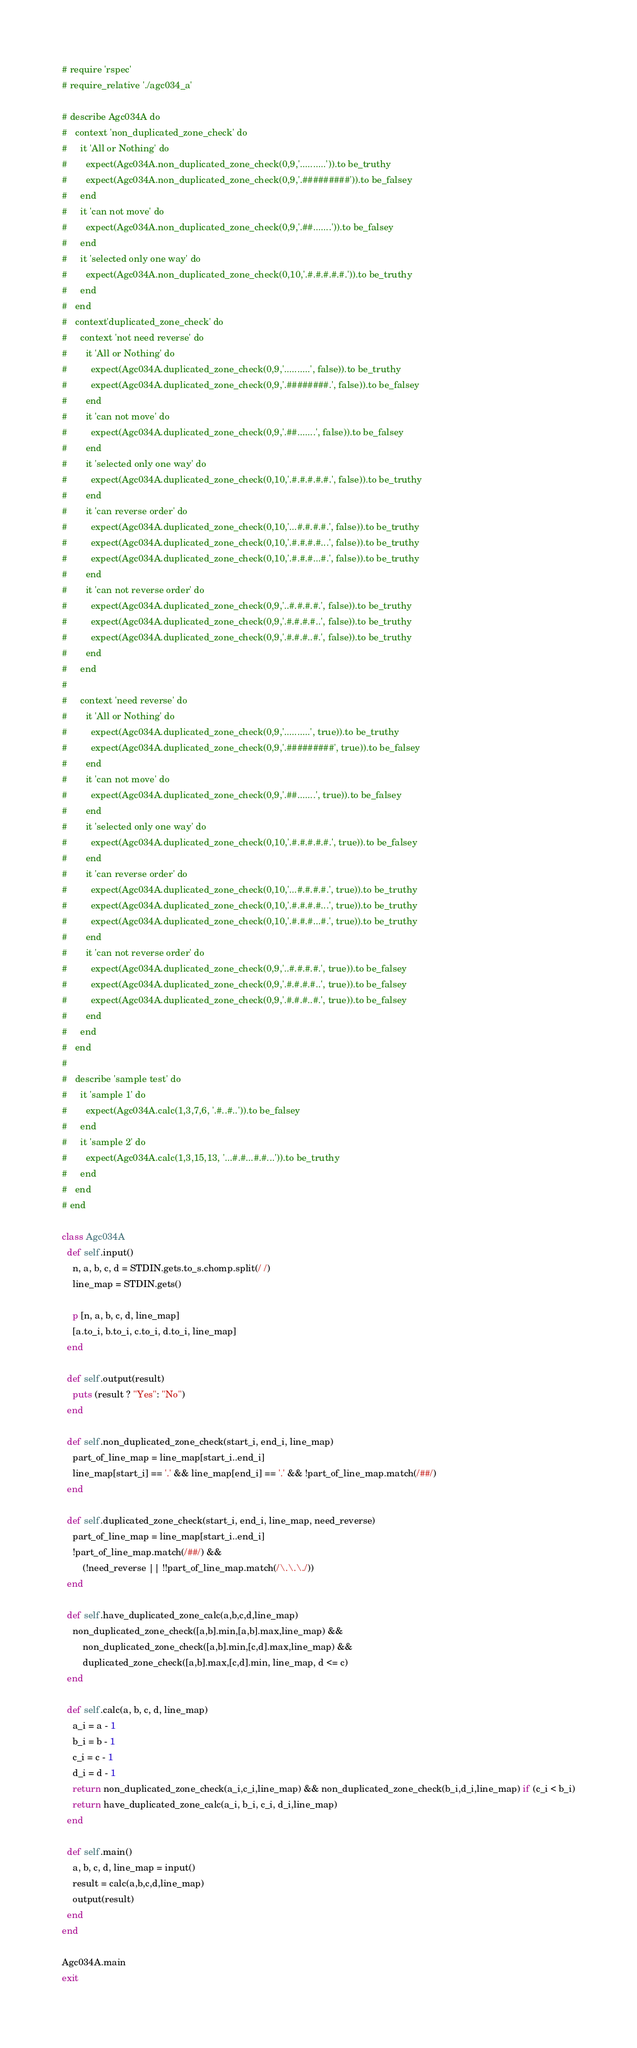Convert code to text. <code><loc_0><loc_0><loc_500><loc_500><_Ruby_># require 'rspec'
# require_relative './agc034_a'

# describe Agc034A do
#   context 'non_duplicated_zone_check' do
#     it 'All or Nothing' do
#       expect(Agc034A.non_duplicated_zone_check(0,9,'..........')).to be_truthy
#       expect(Agc034A.non_duplicated_zone_check(0,9,'.#########')).to be_falsey
#     end
#     it 'can not move' do
#       expect(Agc034A.non_duplicated_zone_check(0,9,'.##.......')).to be_falsey
#     end
#     it 'selected only one way' do
#       expect(Agc034A.non_duplicated_zone_check(0,10,'.#.#.#.#.#.')).to be_truthy
#     end
#   end
#   context'duplicated_zone_check' do
#     context 'not need reverse' do
#       it 'All or Nothing' do
#         expect(Agc034A.duplicated_zone_check(0,9,'..........', false)).to be_truthy
#         expect(Agc034A.duplicated_zone_check(0,9,'.########.', false)).to be_falsey
#       end
#       it 'can not move' do
#         expect(Agc034A.duplicated_zone_check(0,9,'.##.......', false)).to be_falsey
#       end
#       it 'selected only one way' do
#         expect(Agc034A.duplicated_zone_check(0,10,'.#.#.#.#.#.', false)).to be_truthy
#       end
#       it 'can reverse order' do
#         expect(Agc034A.duplicated_zone_check(0,10,'...#.#.#.#.', false)).to be_truthy
#         expect(Agc034A.duplicated_zone_check(0,10,'.#.#.#.#...', false)).to be_truthy
#         expect(Agc034A.duplicated_zone_check(0,10,'.#.#.#...#.', false)).to be_truthy
#       end
#       it 'can not reverse order' do
#         expect(Agc034A.duplicated_zone_check(0,9,'..#.#.#.#.', false)).to be_truthy
#         expect(Agc034A.duplicated_zone_check(0,9,'.#.#.#.#..', false)).to be_truthy
#         expect(Agc034A.duplicated_zone_check(0,9,'.#.#.#..#.', false)).to be_truthy
#       end
#     end
#
#     context 'need reverse' do
#       it 'All or Nothing' do
#         expect(Agc034A.duplicated_zone_check(0,9,'..........', true)).to be_truthy
#         expect(Agc034A.duplicated_zone_check(0,9,'.#########', true)).to be_falsey
#       end
#       it 'can not move' do
#         expect(Agc034A.duplicated_zone_check(0,9,'.##.......', true)).to be_falsey
#       end
#       it 'selected only one way' do
#         expect(Agc034A.duplicated_zone_check(0,10,'.#.#.#.#.#.', true)).to be_falsey
#       end
#       it 'can reverse order' do
#         expect(Agc034A.duplicated_zone_check(0,10,'...#.#.#.#.', true)).to be_truthy
#         expect(Agc034A.duplicated_zone_check(0,10,'.#.#.#.#...', true)).to be_truthy
#         expect(Agc034A.duplicated_zone_check(0,10,'.#.#.#...#.', true)).to be_truthy
#       end
#       it 'can not reverse order' do
#         expect(Agc034A.duplicated_zone_check(0,9,'..#.#.#.#.', true)).to be_falsey
#         expect(Agc034A.duplicated_zone_check(0,9,'.#.#.#.#..', true)).to be_falsey
#         expect(Agc034A.duplicated_zone_check(0,9,'.#.#.#..#.', true)).to be_falsey
#       end
#     end
#   end
#
#   describe 'sample test' do
#     it 'sample 1' do
#       expect(Agc034A.calc(1,3,7,6, '.#..#..')).to be_falsey
#     end
#     it 'sample 2' do
#       expect(Agc034A.calc(1,3,15,13, '...#.#...#.#...')).to be_truthy
#     end
#   end
# end

class Agc034A
  def self.input()
    n, a, b, c, d = STDIN.gets.to_s.chomp.split(/ /)
    line_map = STDIN.gets()

    p [n, a, b, c, d, line_map]
    [a.to_i, b.to_i, c.to_i, d.to_i, line_map]
  end

  def self.output(result)
    puts (result ? "Yes": "No")
  end

  def self.non_duplicated_zone_check(start_i, end_i, line_map)
    part_of_line_map = line_map[start_i..end_i]
    line_map[start_i] == '.' && line_map[end_i] == '.' && !part_of_line_map.match(/##/)
  end

  def self.duplicated_zone_check(start_i, end_i, line_map, need_reverse)
    part_of_line_map = line_map[start_i..end_i]
    !part_of_line_map.match(/##/) &&
        (!need_reverse || !!part_of_line_map.match(/\.\.\./))
  end

  def self.have_duplicated_zone_calc(a,b,c,d,line_map)
    non_duplicated_zone_check([a,b].min,[a,b].max,line_map) &&
        non_duplicated_zone_check([a,b].min,[c,d].max,line_map) &&
        duplicated_zone_check([a,b].max,[c,d].min, line_map, d <= c)
  end

  def self.calc(a, b, c, d, line_map)
    a_i = a - 1
    b_i = b - 1
    c_i = c - 1
    d_i = d - 1
    return non_duplicated_zone_check(a_i,c_i,line_map) && non_duplicated_zone_check(b_i,d_i,line_map) if (c_i < b_i)
    return have_duplicated_zone_calc(a_i, b_i, c_i, d_i,line_map)
  end

  def self.main()
    a, b, c, d, line_map = input()
    result = calc(a,b,c,d,line_map)
    output(result)
  end
end

Agc034A.main
exit</code> 